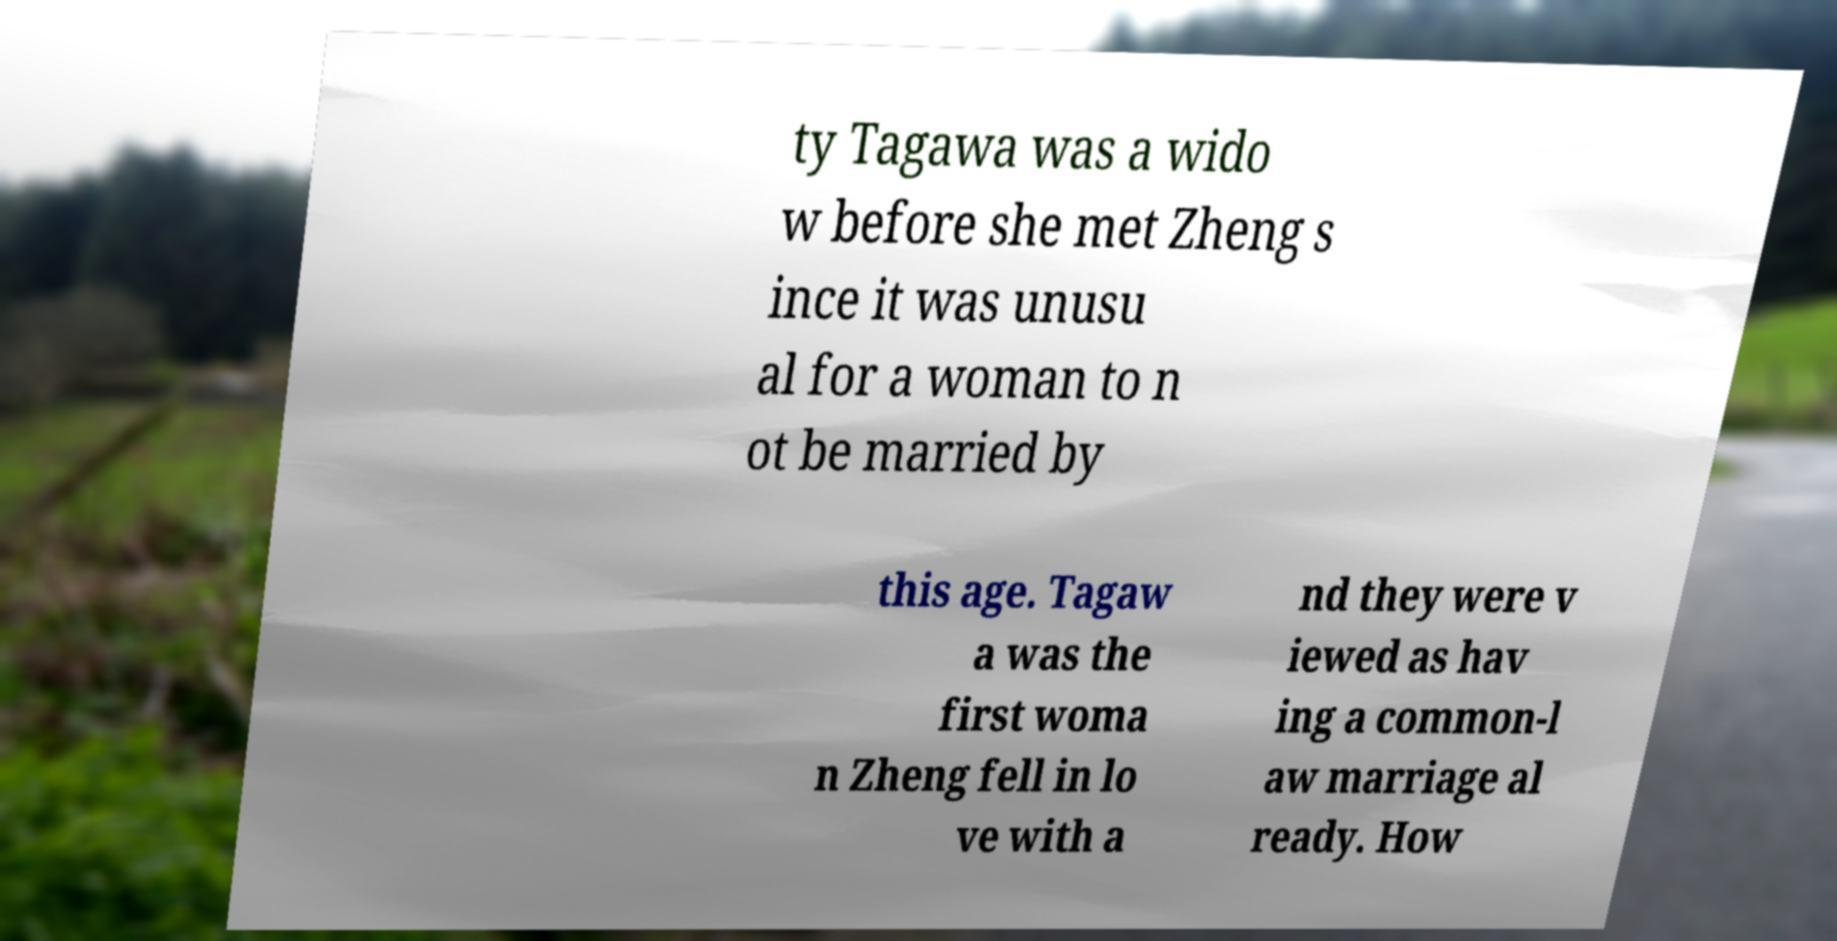What messages or text are displayed in this image? I need them in a readable, typed format. ty Tagawa was a wido w before she met Zheng s ince it was unusu al for a woman to n ot be married by this age. Tagaw a was the first woma n Zheng fell in lo ve with a nd they were v iewed as hav ing a common-l aw marriage al ready. How 